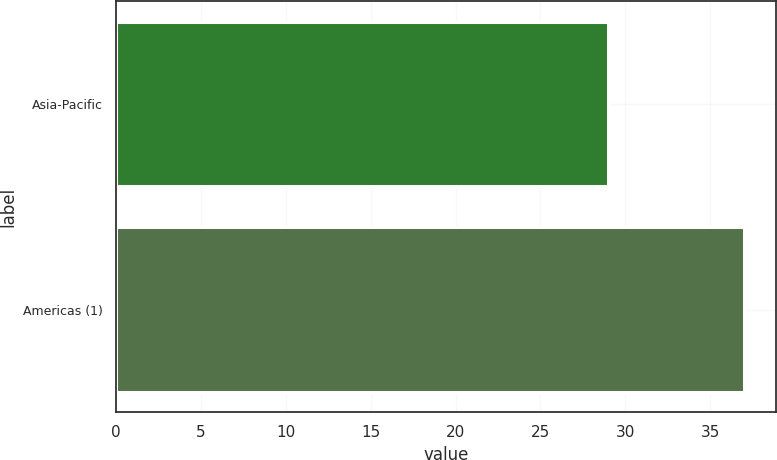Convert chart. <chart><loc_0><loc_0><loc_500><loc_500><bar_chart><fcel>Asia-Pacific<fcel>Americas (1)<nl><fcel>29<fcel>37<nl></chart> 